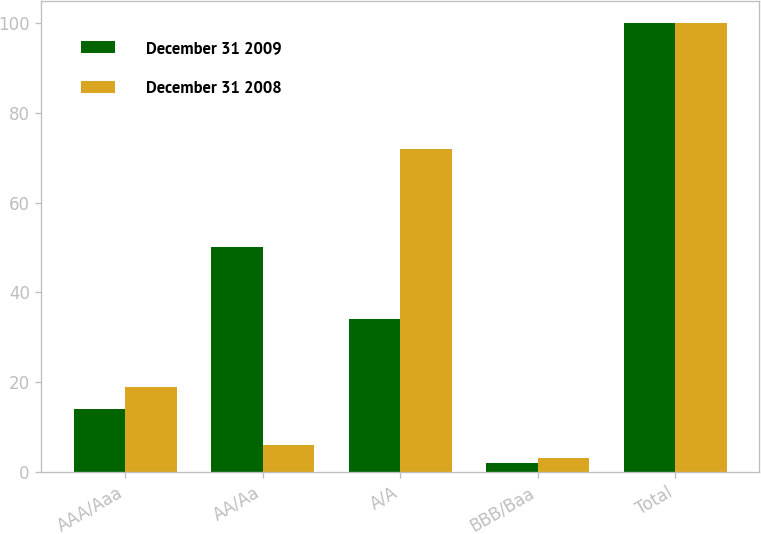Convert chart. <chart><loc_0><loc_0><loc_500><loc_500><stacked_bar_chart><ecel><fcel>AAA/Aaa<fcel>AA/Aa<fcel>A/A<fcel>BBB/Baa<fcel>Total<nl><fcel>December 31 2009<fcel>14<fcel>50<fcel>34<fcel>2<fcel>100<nl><fcel>December 31 2008<fcel>19<fcel>6<fcel>72<fcel>3<fcel>100<nl></chart> 